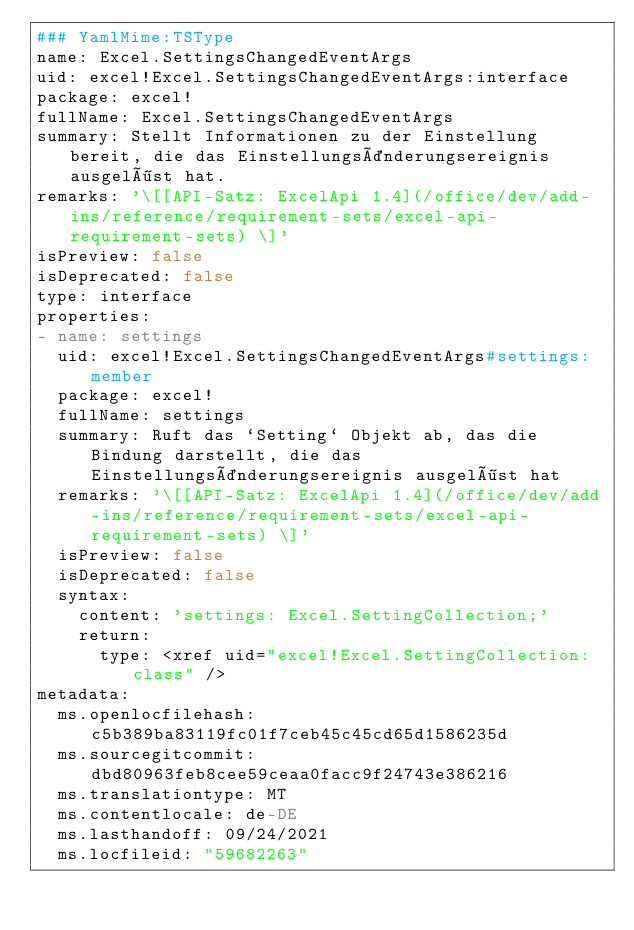Convert code to text. <code><loc_0><loc_0><loc_500><loc_500><_YAML_>### YamlMime:TSType
name: Excel.SettingsChangedEventArgs
uid: excel!Excel.SettingsChangedEventArgs:interface
package: excel!
fullName: Excel.SettingsChangedEventArgs
summary: Stellt Informationen zu der Einstellung bereit, die das Einstellungsänderungsereignis ausgelöst hat.
remarks: '\[[API-Satz: ExcelApi 1.4](/office/dev/add-ins/reference/requirement-sets/excel-api-requirement-sets) \]'
isPreview: false
isDeprecated: false
type: interface
properties:
- name: settings
  uid: excel!Excel.SettingsChangedEventArgs#settings:member
  package: excel!
  fullName: settings
  summary: Ruft das `Setting` Objekt ab, das die Bindung darstellt, die das Einstellungsänderungsereignis ausgelöst hat
  remarks: '\[[API-Satz: ExcelApi 1.4](/office/dev/add-ins/reference/requirement-sets/excel-api-requirement-sets) \]'
  isPreview: false
  isDeprecated: false
  syntax:
    content: 'settings: Excel.SettingCollection;'
    return:
      type: <xref uid="excel!Excel.SettingCollection:class" />
metadata:
  ms.openlocfilehash: c5b389ba83119fc01f7ceb45c45cd65d1586235d
  ms.sourcegitcommit: dbd80963feb8cee59ceaa0facc9f24743e386216
  ms.translationtype: MT
  ms.contentlocale: de-DE
  ms.lasthandoff: 09/24/2021
  ms.locfileid: "59682263"
</code> 